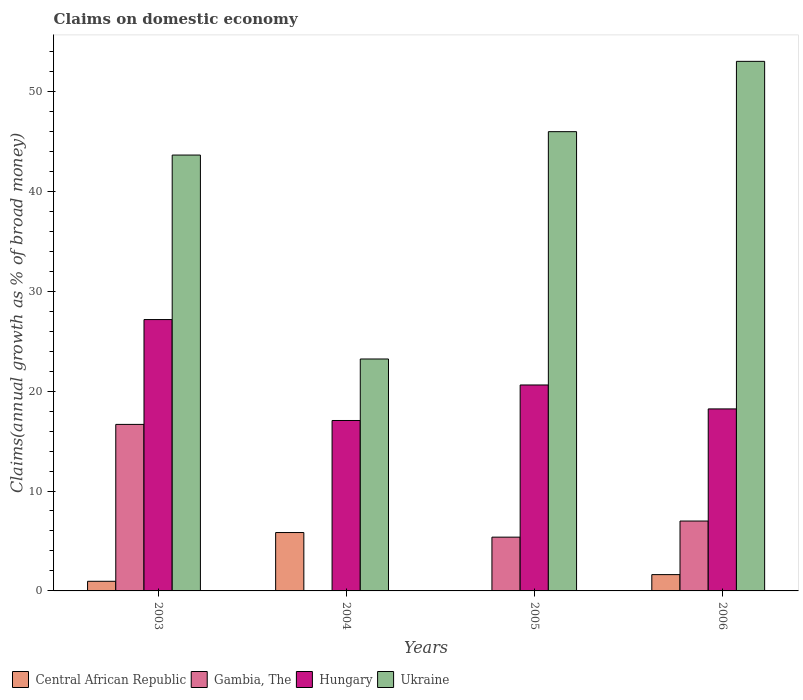How many different coloured bars are there?
Give a very brief answer. 4. How many groups of bars are there?
Make the answer very short. 4. Are the number of bars per tick equal to the number of legend labels?
Offer a very short reply. No. Are the number of bars on each tick of the X-axis equal?
Your answer should be compact. No. How many bars are there on the 1st tick from the left?
Make the answer very short. 4. What is the label of the 4th group of bars from the left?
Keep it short and to the point. 2006. In how many cases, is the number of bars for a given year not equal to the number of legend labels?
Offer a terse response. 2. What is the percentage of broad money claimed on domestic economy in Hungary in 2005?
Your answer should be compact. 20.61. Across all years, what is the maximum percentage of broad money claimed on domestic economy in Hungary?
Ensure brevity in your answer.  27.16. Across all years, what is the minimum percentage of broad money claimed on domestic economy in Gambia, The?
Ensure brevity in your answer.  0. In which year was the percentage of broad money claimed on domestic economy in Ukraine maximum?
Ensure brevity in your answer.  2006. What is the total percentage of broad money claimed on domestic economy in Gambia, The in the graph?
Make the answer very short. 29.05. What is the difference between the percentage of broad money claimed on domestic economy in Hungary in 2004 and that in 2005?
Make the answer very short. -3.56. What is the difference between the percentage of broad money claimed on domestic economy in Ukraine in 2005 and the percentage of broad money claimed on domestic economy in Hungary in 2004?
Your response must be concise. 28.91. What is the average percentage of broad money claimed on domestic economy in Gambia, The per year?
Keep it short and to the point. 7.26. In the year 2003, what is the difference between the percentage of broad money claimed on domestic economy in Gambia, The and percentage of broad money claimed on domestic economy in Hungary?
Keep it short and to the point. -10.49. What is the ratio of the percentage of broad money claimed on domestic economy in Central African Republic in 2003 to that in 2004?
Your response must be concise. 0.17. Is the percentage of broad money claimed on domestic economy in Ukraine in 2005 less than that in 2006?
Give a very brief answer. Yes. Is the difference between the percentage of broad money claimed on domestic economy in Gambia, The in 2003 and 2006 greater than the difference between the percentage of broad money claimed on domestic economy in Hungary in 2003 and 2006?
Your response must be concise. Yes. What is the difference between the highest and the second highest percentage of broad money claimed on domestic economy in Gambia, The?
Offer a terse response. 9.67. What is the difference between the highest and the lowest percentage of broad money claimed on domestic economy in Ukraine?
Keep it short and to the point. 29.79. Is the sum of the percentage of broad money claimed on domestic economy in Central African Republic in 2003 and 2006 greater than the maximum percentage of broad money claimed on domestic economy in Ukraine across all years?
Your answer should be compact. No. Is it the case that in every year, the sum of the percentage of broad money claimed on domestic economy in Ukraine and percentage of broad money claimed on domestic economy in Gambia, The is greater than the sum of percentage of broad money claimed on domestic economy in Central African Republic and percentage of broad money claimed on domestic economy in Hungary?
Keep it short and to the point. No. Is it the case that in every year, the sum of the percentage of broad money claimed on domestic economy in Hungary and percentage of broad money claimed on domestic economy in Central African Republic is greater than the percentage of broad money claimed on domestic economy in Gambia, The?
Your response must be concise. Yes. Are all the bars in the graph horizontal?
Ensure brevity in your answer.  No. Does the graph contain grids?
Offer a terse response. No. Where does the legend appear in the graph?
Your answer should be very brief. Bottom left. How many legend labels are there?
Your answer should be compact. 4. What is the title of the graph?
Your response must be concise. Claims on domestic economy. Does "Sri Lanka" appear as one of the legend labels in the graph?
Your answer should be compact. No. What is the label or title of the Y-axis?
Keep it short and to the point. Claims(annual growth as % of broad money). What is the Claims(annual growth as % of broad money) of Central African Republic in 2003?
Offer a very short reply. 0.96. What is the Claims(annual growth as % of broad money) of Gambia, The in 2003?
Provide a succinct answer. 16.67. What is the Claims(annual growth as % of broad money) in Hungary in 2003?
Your answer should be very brief. 27.16. What is the Claims(annual growth as % of broad money) of Ukraine in 2003?
Your answer should be very brief. 43.63. What is the Claims(annual growth as % of broad money) of Central African Republic in 2004?
Offer a very short reply. 5.84. What is the Claims(annual growth as % of broad money) in Gambia, The in 2004?
Ensure brevity in your answer.  0. What is the Claims(annual growth as % of broad money) in Hungary in 2004?
Provide a short and direct response. 17.06. What is the Claims(annual growth as % of broad money) of Ukraine in 2004?
Make the answer very short. 23.21. What is the Claims(annual growth as % of broad money) in Central African Republic in 2005?
Your answer should be very brief. 0. What is the Claims(annual growth as % of broad money) of Gambia, The in 2005?
Your answer should be very brief. 5.38. What is the Claims(annual growth as % of broad money) in Hungary in 2005?
Give a very brief answer. 20.61. What is the Claims(annual growth as % of broad money) in Ukraine in 2005?
Offer a very short reply. 45.97. What is the Claims(annual growth as % of broad money) in Central African Republic in 2006?
Provide a succinct answer. 1.63. What is the Claims(annual growth as % of broad money) in Gambia, The in 2006?
Ensure brevity in your answer.  6.99. What is the Claims(annual growth as % of broad money) of Hungary in 2006?
Make the answer very short. 18.22. What is the Claims(annual growth as % of broad money) of Ukraine in 2006?
Ensure brevity in your answer.  53. Across all years, what is the maximum Claims(annual growth as % of broad money) of Central African Republic?
Your answer should be compact. 5.84. Across all years, what is the maximum Claims(annual growth as % of broad money) in Gambia, The?
Offer a terse response. 16.67. Across all years, what is the maximum Claims(annual growth as % of broad money) in Hungary?
Your answer should be compact. 27.16. Across all years, what is the maximum Claims(annual growth as % of broad money) in Ukraine?
Your response must be concise. 53. Across all years, what is the minimum Claims(annual growth as % of broad money) of Hungary?
Give a very brief answer. 17.06. Across all years, what is the minimum Claims(annual growth as % of broad money) of Ukraine?
Offer a terse response. 23.21. What is the total Claims(annual growth as % of broad money) in Central African Republic in the graph?
Provide a short and direct response. 8.44. What is the total Claims(annual growth as % of broad money) in Gambia, The in the graph?
Keep it short and to the point. 29.05. What is the total Claims(annual growth as % of broad money) in Hungary in the graph?
Ensure brevity in your answer.  83.05. What is the total Claims(annual growth as % of broad money) in Ukraine in the graph?
Make the answer very short. 165.81. What is the difference between the Claims(annual growth as % of broad money) of Central African Republic in 2003 and that in 2004?
Your response must be concise. -4.88. What is the difference between the Claims(annual growth as % of broad money) in Hungary in 2003 and that in 2004?
Your answer should be very brief. 10.1. What is the difference between the Claims(annual growth as % of broad money) in Ukraine in 2003 and that in 2004?
Your answer should be compact. 20.41. What is the difference between the Claims(annual growth as % of broad money) in Gambia, The in 2003 and that in 2005?
Provide a short and direct response. 11.29. What is the difference between the Claims(annual growth as % of broad money) of Hungary in 2003 and that in 2005?
Offer a very short reply. 6.55. What is the difference between the Claims(annual growth as % of broad money) in Ukraine in 2003 and that in 2005?
Offer a terse response. -2.34. What is the difference between the Claims(annual growth as % of broad money) in Central African Republic in 2003 and that in 2006?
Your answer should be very brief. -0.67. What is the difference between the Claims(annual growth as % of broad money) of Gambia, The in 2003 and that in 2006?
Make the answer very short. 9.67. What is the difference between the Claims(annual growth as % of broad money) of Hungary in 2003 and that in 2006?
Provide a short and direct response. 8.94. What is the difference between the Claims(annual growth as % of broad money) of Ukraine in 2003 and that in 2006?
Make the answer very short. -9.38. What is the difference between the Claims(annual growth as % of broad money) in Hungary in 2004 and that in 2005?
Offer a very short reply. -3.56. What is the difference between the Claims(annual growth as % of broad money) in Ukraine in 2004 and that in 2005?
Provide a short and direct response. -22.75. What is the difference between the Claims(annual growth as % of broad money) of Central African Republic in 2004 and that in 2006?
Your answer should be compact. 4.21. What is the difference between the Claims(annual growth as % of broad money) of Hungary in 2004 and that in 2006?
Give a very brief answer. -1.16. What is the difference between the Claims(annual growth as % of broad money) in Ukraine in 2004 and that in 2006?
Provide a short and direct response. -29.79. What is the difference between the Claims(annual growth as % of broad money) in Gambia, The in 2005 and that in 2006?
Your answer should be compact. -1.61. What is the difference between the Claims(annual growth as % of broad money) of Hungary in 2005 and that in 2006?
Your response must be concise. 2.4. What is the difference between the Claims(annual growth as % of broad money) in Ukraine in 2005 and that in 2006?
Make the answer very short. -7.04. What is the difference between the Claims(annual growth as % of broad money) in Central African Republic in 2003 and the Claims(annual growth as % of broad money) in Hungary in 2004?
Offer a very short reply. -16.09. What is the difference between the Claims(annual growth as % of broad money) in Central African Republic in 2003 and the Claims(annual growth as % of broad money) in Ukraine in 2004?
Your response must be concise. -22.25. What is the difference between the Claims(annual growth as % of broad money) in Gambia, The in 2003 and the Claims(annual growth as % of broad money) in Hungary in 2004?
Offer a terse response. -0.39. What is the difference between the Claims(annual growth as % of broad money) in Gambia, The in 2003 and the Claims(annual growth as % of broad money) in Ukraine in 2004?
Your answer should be compact. -6.55. What is the difference between the Claims(annual growth as % of broad money) in Hungary in 2003 and the Claims(annual growth as % of broad money) in Ukraine in 2004?
Your answer should be very brief. 3.95. What is the difference between the Claims(annual growth as % of broad money) in Central African Republic in 2003 and the Claims(annual growth as % of broad money) in Gambia, The in 2005?
Your response must be concise. -4.42. What is the difference between the Claims(annual growth as % of broad money) of Central African Republic in 2003 and the Claims(annual growth as % of broad money) of Hungary in 2005?
Ensure brevity in your answer.  -19.65. What is the difference between the Claims(annual growth as % of broad money) in Central African Republic in 2003 and the Claims(annual growth as % of broad money) in Ukraine in 2005?
Make the answer very short. -45. What is the difference between the Claims(annual growth as % of broad money) of Gambia, The in 2003 and the Claims(annual growth as % of broad money) of Hungary in 2005?
Give a very brief answer. -3.95. What is the difference between the Claims(annual growth as % of broad money) of Gambia, The in 2003 and the Claims(annual growth as % of broad money) of Ukraine in 2005?
Your answer should be compact. -29.3. What is the difference between the Claims(annual growth as % of broad money) of Hungary in 2003 and the Claims(annual growth as % of broad money) of Ukraine in 2005?
Your answer should be very brief. -18.81. What is the difference between the Claims(annual growth as % of broad money) in Central African Republic in 2003 and the Claims(annual growth as % of broad money) in Gambia, The in 2006?
Give a very brief answer. -6.03. What is the difference between the Claims(annual growth as % of broad money) of Central African Republic in 2003 and the Claims(annual growth as % of broad money) of Hungary in 2006?
Provide a succinct answer. -17.25. What is the difference between the Claims(annual growth as % of broad money) of Central African Republic in 2003 and the Claims(annual growth as % of broad money) of Ukraine in 2006?
Ensure brevity in your answer.  -52.04. What is the difference between the Claims(annual growth as % of broad money) in Gambia, The in 2003 and the Claims(annual growth as % of broad money) in Hungary in 2006?
Give a very brief answer. -1.55. What is the difference between the Claims(annual growth as % of broad money) in Gambia, The in 2003 and the Claims(annual growth as % of broad money) in Ukraine in 2006?
Offer a terse response. -36.34. What is the difference between the Claims(annual growth as % of broad money) of Hungary in 2003 and the Claims(annual growth as % of broad money) of Ukraine in 2006?
Provide a succinct answer. -25.85. What is the difference between the Claims(annual growth as % of broad money) in Central African Republic in 2004 and the Claims(annual growth as % of broad money) in Gambia, The in 2005?
Give a very brief answer. 0.46. What is the difference between the Claims(annual growth as % of broad money) in Central African Republic in 2004 and the Claims(annual growth as % of broad money) in Hungary in 2005?
Offer a terse response. -14.77. What is the difference between the Claims(annual growth as % of broad money) in Central African Republic in 2004 and the Claims(annual growth as % of broad money) in Ukraine in 2005?
Offer a terse response. -40.12. What is the difference between the Claims(annual growth as % of broad money) of Hungary in 2004 and the Claims(annual growth as % of broad money) of Ukraine in 2005?
Keep it short and to the point. -28.91. What is the difference between the Claims(annual growth as % of broad money) in Central African Republic in 2004 and the Claims(annual growth as % of broad money) in Gambia, The in 2006?
Provide a succinct answer. -1.15. What is the difference between the Claims(annual growth as % of broad money) in Central African Republic in 2004 and the Claims(annual growth as % of broad money) in Hungary in 2006?
Your answer should be compact. -12.37. What is the difference between the Claims(annual growth as % of broad money) in Central African Republic in 2004 and the Claims(annual growth as % of broad money) in Ukraine in 2006?
Ensure brevity in your answer.  -47.16. What is the difference between the Claims(annual growth as % of broad money) in Hungary in 2004 and the Claims(annual growth as % of broad money) in Ukraine in 2006?
Offer a very short reply. -35.95. What is the difference between the Claims(annual growth as % of broad money) of Gambia, The in 2005 and the Claims(annual growth as % of broad money) of Hungary in 2006?
Ensure brevity in your answer.  -12.83. What is the difference between the Claims(annual growth as % of broad money) of Gambia, The in 2005 and the Claims(annual growth as % of broad money) of Ukraine in 2006?
Your answer should be very brief. -47.62. What is the difference between the Claims(annual growth as % of broad money) in Hungary in 2005 and the Claims(annual growth as % of broad money) in Ukraine in 2006?
Your answer should be very brief. -32.39. What is the average Claims(annual growth as % of broad money) in Central African Republic per year?
Offer a terse response. 2.11. What is the average Claims(annual growth as % of broad money) in Gambia, The per year?
Your answer should be very brief. 7.26. What is the average Claims(annual growth as % of broad money) of Hungary per year?
Ensure brevity in your answer.  20.76. What is the average Claims(annual growth as % of broad money) in Ukraine per year?
Offer a terse response. 41.45. In the year 2003, what is the difference between the Claims(annual growth as % of broad money) in Central African Republic and Claims(annual growth as % of broad money) in Gambia, The?
Keep it short and to the point. -15.7. In the year 2003, what is the difference between the Claims(annual growth as % of broad money) of Central African Republic and Claims(annual growth as % of broad money) of Hungary?
Make the answer very short. -26.2. In the year 2003, what is the difference between the Claims(annual growth as % of broad money) of Central African Republic and Claims(annual growth as % of broad money) of Ukraine?
Make the answer very short. -42.66. In the year 2003, what is the difference between the Claims(annual growth as % of broad money) in Gambia, The and Claims(annual growth as % of broad money) in Hungary?
Keep it short and to the point. -10.49. In the year 2003, what is the difference between the Claims(annual growth as % of broad money) in Gambia, The and Claims(annual growth as % of broad money) in Ukraine?
Offer a very short reply. -26.96. In the year 2003, what is the difference between the Claims(annual growth as % of broad money) of Hungary and Claims(annual growth as % of broad money) of Ukraine?
Make the answer very short. -16.47. In the year 2004, what is the difference between the Claims(annual growth as % of broad money) in Central African Republic and Claims(annual growth as % of broad money) in Hungary?
Your answer should be very brief. -11.21. In the year 2004, what is the difference between the Claims(annual growth as % of broad money) of Central African Republic and Claims(annual growth as % of broad money) of Ukraine?
Your answer should be compact. -17.37. In the year 2004, what is the difference between the Claims(annual growth as % of broad money) of Hungary and Claims(annual growth as % of broad money) of Ukraine?
Give a very brief answer. -6.16. In the year 2005, what is the difference between the Claims(annual growth as % of broad money) of Gambia, The and Claims(annual growth as % of broad money) of Hungary?
Make the answer very short. -15.23. In the year 2005, what is the difference between the Claims(annual growth as % of broad money) in Gambia, The and Claims(annual growth as % of broad money) in Ukraine?
Ensure brevity in your answer.  -40.58. In the year 2005, what is the difference between the Claims(annual growth as % of broad money) of Hungary and Claims(annual growth as % of broad money) of Ukraine?
Your answer should be compact. -25.35. In the year 2006, what is the difference between the Claims(annual growth as % of broad money) in Central African Republic and Claims(annual growth as % of broad money) in Gambia, The?
Keep it short and to the point. -5.36. In the year 2006, what is the difference between the Claims(annual growth as % of broad money) in Central African Republic and Claims(annual growth as % of broad money) in Hungary?
Offer a very short reply. -16.59. In the year 2006, what is the difference between the Claims(annual growth as % of broad money) of Central African Republic and Claims(annual growth as % of broad money) of Ukraine?
Ensure brevity in your answer.  -51.37. In the year 2006, what is the difference between the Claims(annual growth as % of broad money) of Gambia, The and Claims(annual growth as % of broad money) of Hungary?
Ensure brevity in your answer.  -11.22. In the year 2006, what is the difference between the Claims(annual growth as % of broad money) in Gambia, The and Claims(annual growth as % of broad money) in Ukraine?
Offer a terse response. -46.01. In the year 2006, what is the difference between the Claims(annual growth as % of broad money) of Hungary and Claims(annual growth as % of broad money) of Ukraine?
Your answer should be very brief. -34.79. What is the ratio of the Claims(annual growth as % of broad money) of Central African Republic in 2003 to that in 2004?
Your response must be concise. 0.17. What is the ratio of the Claims(annual growth as % of broad money) in Hungary in 2003 to that in 2004?
Offer a terse response. 1.59. What is the ratio of the Claims(annual growth as % of broad money) of Ukraine in 2003 to that in 2004?
Your answer should be very brief. 1.88. What is the ratio of the Claims(annual growth as % of broad money) of Gambia, The in 2003 to that in 2005?
Keep it short and to the point. 3.1. What is the ratio of the Claims(annual growth as % of broad money) of Hungary in 2003 to that in 2005?
Provide a short and direct response. 1.32. What is the ratio of the Claims(annual growth as % of broad money) in Ukraine in 2003 to that in 2005?
Keep it short and to the point. 0.95. What is the ratio of the Claims(annual growth as % of broad money) in Central African Republic in 2003 to that in 2006?
Your answer should be compact. 0.59. What is the ratio of the Claims(annual growth as % of broad money) in Gambia, The in 2003 to that in 2006?
Make the answer very short. 2.38. What is the ratio of the Claims(annual growth as % of broad money) of Hungary in 2003 to that in 2006?
Your answer should be compact. 1.49. What is the ratio of the Claims(annual growth as % of broad money) in Ukraine in 2003 to that in 2006?
Your answer should be compact. 0.82. What is the ratio of the Claims(annual growth as % of broad money) in Hungary in 2004 to that in 2005?
Keep it short and to the point. 0.83. What is the ratio of the Claims(annual growth as % of broad money) of Ukraine in 2004 to that in 2005?
Keep it short and to the point. 0.51. What is the ratio of the Claims(annual growth as % of broad money) of Central African Republic in 2004 to that in 2006?
Keep it short and to the point. 3.58. What is the ratio of the Claims(annual growth as % of broad money) in Hungary in 2004 to that in 2006?
Offer a terse response. 0.94. What is the ratio of the Claims(annual growth as % of broad money) of Ukraine in 2004 to that in 2006?
Your answer should be compact. 0.44. What is the ratio of the Claims(annual growth as % of broad money) in Gambia, The in 2005 to that in 2006?
Provide a succinct answer. 0.77. What is the ratio of the Claims(annual growth as % of broad money) in Hungary in 2005 to that in 2006?
Make the answer very short. 1.13. What is the ratio of the Claims(annual growth as % of broad money) of Ukraine in 2005 to that in 2006?
Your answer should be compact. 0.87. What is the difference between the highest and the second highest Claims(annual growth as % of broad money) in Central African Republic?
Offer a very short reply. 4.21. What is the difference between the highest and the second highest Claims(annual growth as % of broad money) in Gambia, The?
Your response must be concise. 9.67. What is the difference between the highest and the second highest Claims(annual growth as % of broad money) in Hungary?
Provide a short and direct response. 6.55. What is the difference between the highest and the second highest Claims(annual growth as % of broad money) in Ukraine?
Your answer should be very brief. 7.04. What is the difference between the highest and the lowest Claims(annual growth as % of broad money) in Central African Republic?
Give a very brief answer. 5.84. What is the difference between the highest and the lowest Claims(annual growth as % of broad money) of Gambia, The?
Provide a succinct answer. 16.67. What is the difference between the highest and the lowest Claims(annual growth as % of broad money) in Hungary?
Your answer should be compact. 10.1. What is the difference between the highest and the lowest Claims(annual growth as % of broad money) in Ukraine?
Offer a terse response. 29.79. 